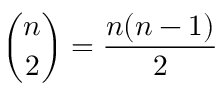Convert formula to latex. <formula><loc_0><loc_0><loc_500><loc_500>{ \binom { n } { 2 } } = { \frac { n ( n - 1 ) } { 2 } }</formula> 